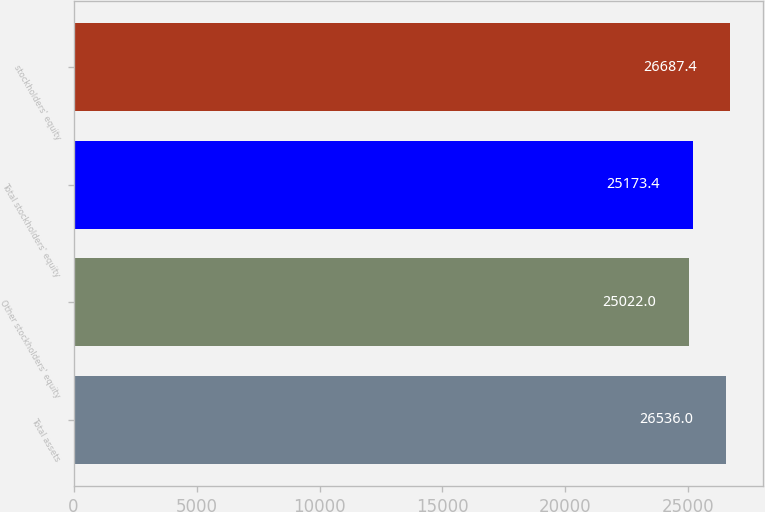<chart> <loc_0><loc_0><loc_500><loc_500><bar_chart><fcel>Total assets<fcel>Other stockholders' equity<fcel>Total stockholders' equity<fcel>stockholders' equity<nl><fcel>26536<fcel>25022<fcel>25173.4<fcel>26687.4<nl></chart> 